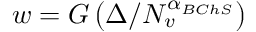<formula> <loc_0><loc_0><loc_500><loc_500>w = G \left ( \Delta / N _ { v } ^ { \alpha _ { B C h S } } \right )</formula> 